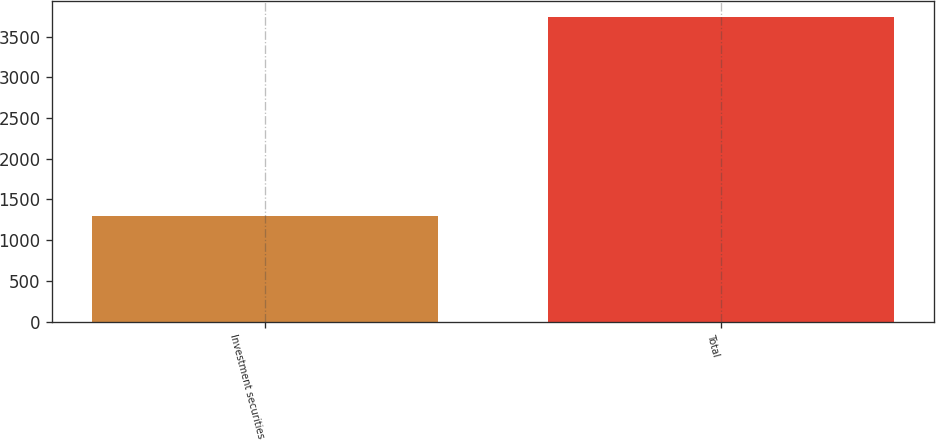Convert chart. <chart><loc_0><loc_0><loc_500><loc_500><bar_chart><fcel>Investment securities<fcel>Total<nl><fcel>1298<fcel>3748<nl></chart> 